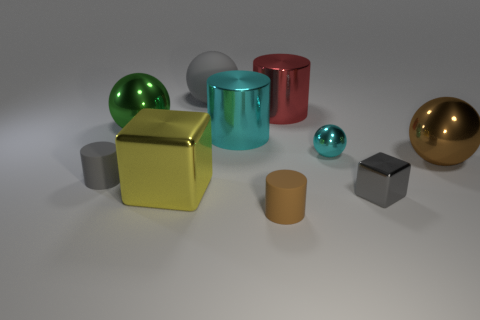Subtract all tiny brown matte cylinders. How many cylinders are left? 3 Subtract all cyan cylinders. How many cylinders are left? 3 Subtract 4 balls. How many balls are left? 0 Subtract all green balls. Subtract all brown blocks. How many balls are left? 3 Subtract all green blocks. How many brown cylinders are left? 1 Subtract all large cyan metal objects. Subtract all brown objects. How many objects are left? 7 Add 4 big green spheres. How many big green spheres are left? 5 Add 2 tiny things. How many tiny things exist? 6 Subtract 0 red cubes. How many objects are left? 10 Subtract all spheres. How many objects are left? 6 